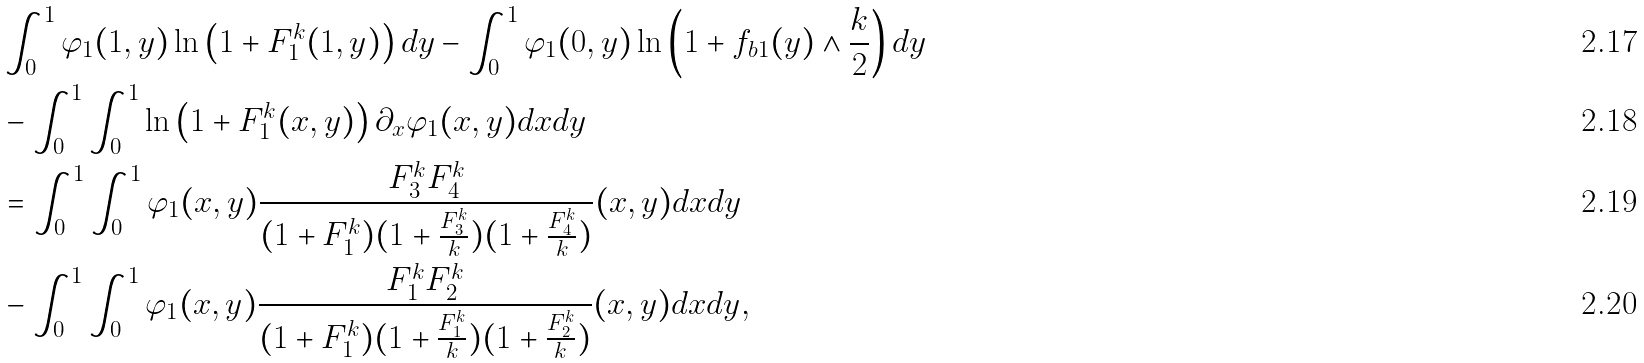Convert formula to latex. <formula><loc_0><loc_0><loc_500><loc_500>& \int _ { 0 } ^ { 1 } \varphi _ { 1 } ( 1 , y ) \ln \left ( 1 + F ^ { k } _ { 1 } ( 1 , y ) \right ) d y - \int _ { 0 } ^ { 1 } \varphi _ { 1 } ( 0 , y ) \ln \left ( 1 + f _ { b 1 } ( y ) \wedge \frac { k } { 2 } \right ) d y \\ & - \int _ { 0 } ^ { 1 } \int _ { 0 } ^ { 1 } \ln \left ( 1 + F ^ { k } _ { 1 } ( x , y ) \right ) \partial _ { x } \varphi _ { 1 } ( x , y ) d x d y \\ & = \int _ { 0 } ^ { 1 } \int _ { 0 } ^ { 1 } \varphi _ { 1 } ( x , y ) \frac { F ^ { k } _ { 3 } F ^ { k } _ { 4 } } { ( 1 + F ^ { k } _ { 1 } ) ( 1 + \frac { F ^ { k } _ { 3 } } { k } ) ( 1 + \frac { F ^ { k } _ { 4 } } { k } ) } ( x , y ) d x d y \\ & - \int _ { 0 } ^ { 1 } \int _ { 0 } ^ { 1 } \varphi _ { 1 } ( x , y ) \frac { F ^ { k } _ { 1 } F ^ { k } _ { 2 } } { ( 1 + F ^ { k } _ { 1 } ) ( 1 + \frac { F ^ { k } _ { 1 } } { k } ) ( 1 + \frac { F ^ { k } _ { 2 } } { k } ) } ( x , y ) d x d y ,</formula> 